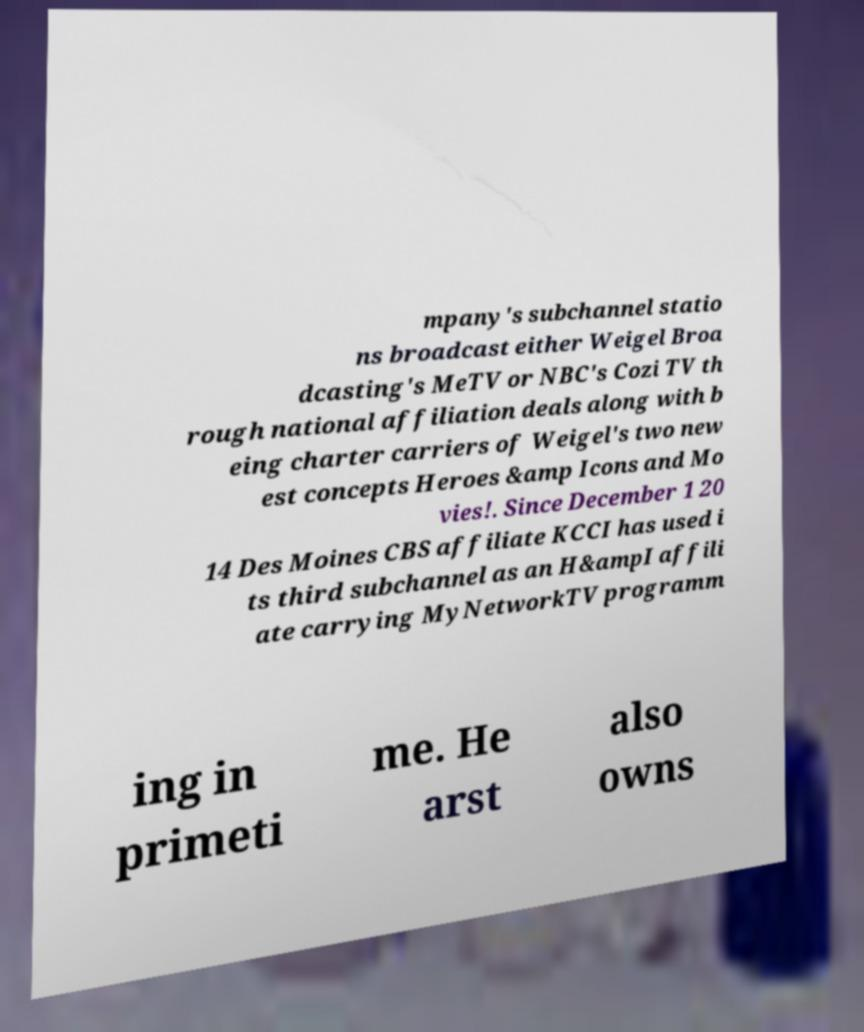Please read and relay the text visible in this image. What does it say? mpany's subchannel statio ns broadcast either Weigel Broa dcasting's MeTV or NBC's Cozi TV th rough national affiliation deals along with b eing charter carriers of Weigel's two new est concepts Heroes &amp Icons and Mo vies!. Since December 1 20 14 Des Moines CBS affiliate KCCI has used i ts third subchannel as an H&ampI affili ate carrying MyNetworkTV programm ing in primeti me. He arst also owns 